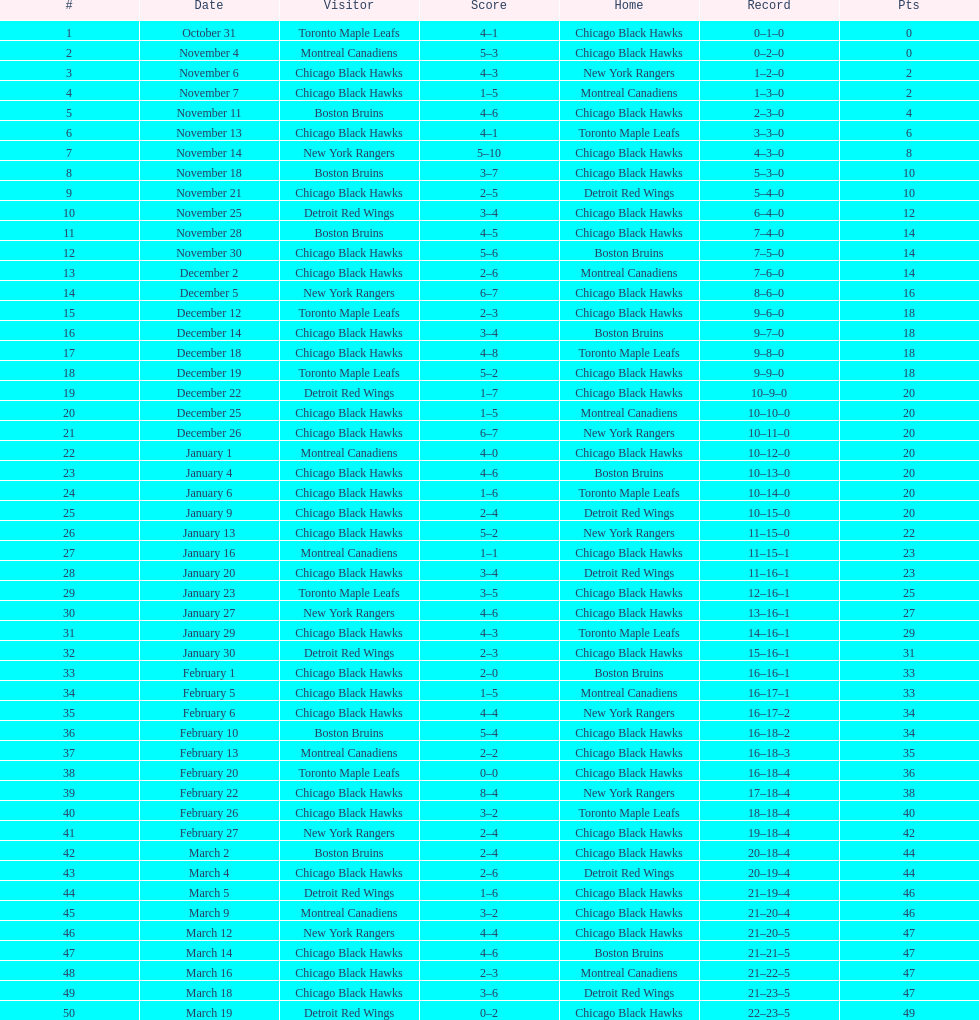How long is the duration of one season (from the first game to the last)? 5 months. 